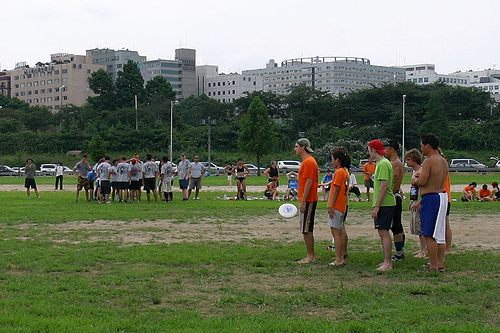<image>
Is there a white team on the grass? Yes. Looking at the image, I can see the white team is positioned on top of the grass, with the grass providing support. Where is the hat in relation to the boy? Is it on the boy? No. The hat is not positioned on the boy. They may be near each other, but the hat is not supported by or resting on top of the boy. 